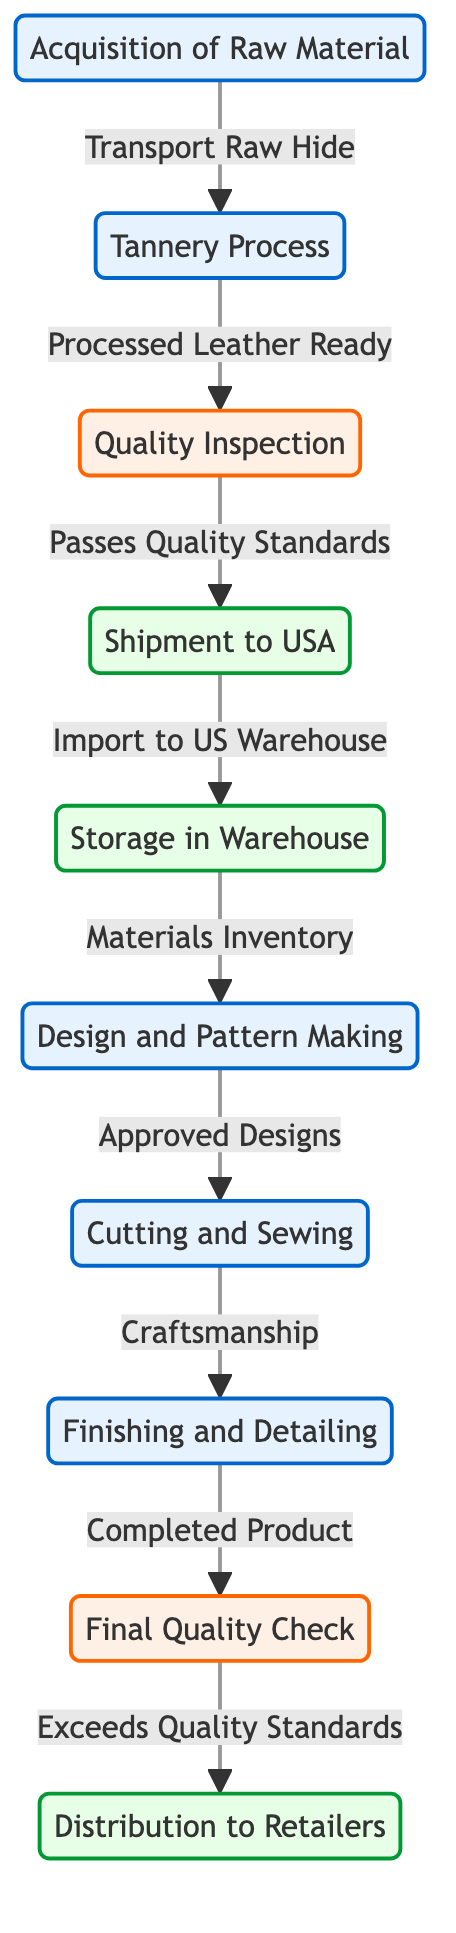What is the first step in the supply chain? The diagram shows that the very first step in the supply chain is "Acquisition of Raw Material." This is represented as the starting node connected to the tannery process.
Answer: Acquisition of Raw Material How many quality inspection points are in the diagram? There are two quality inspection points indicated in the diagram: "Quality Inspection" and "Final Quality Check." The count is derived by simply identifying the unique nodes that involve quality assessment.
Answer: 2 Which process follows "Tannery Process"? According to the diagram flow, the process that directly follows "Tannery Process" is "Quality Inspection." This relationship is illustrated with a directed arrow leading from the tannery to the inspection node.
Answer: Quality Inspection What step is taken before distribution to retailers? Before distribution to retailers, the last step in the process is "Final Quality Check." This step ensures that the products meet the required quality standards prior to being sent out for distribution.
Answer: Final Quality Check What material is transported to the tannery? The material that is transported to the tannery is "Raw Hide." This is specifically mentioned as part of the process indicated in the arrow leading from raw material to the tannery.
Answer: Raw Hide What is the last process in the supply chain? The last process depicted in the diagram is "Distribution to Retailers." This is the final step that completes the supply chain workflow for the Italian leather products.
Answer: Distribution to Retailers What happens to the processed leather after the quality inspection? After the quality inspection, the processed leather that passes quality standards is sent for "Shipment to USA." This indicates the next step in the supply chain after inspection.
Answer: Shipment to USA How many processes are there in total from raw material to finished product? The total number of processes from "Acquisition of Raw Material" to "Distribution to Retailers" can be counted as eight distinct process nodes linked in sequential order.
Answer: 8 What is the role of "Design and Pattern Making" in the supply chain? "Design and Pattern Making" serves as a critical step in the supply chain, where approved designs are created prior to moving on to manufacturing. This step facilitates the crafting of products that meet design specifications.
Answer: Approved Designs 